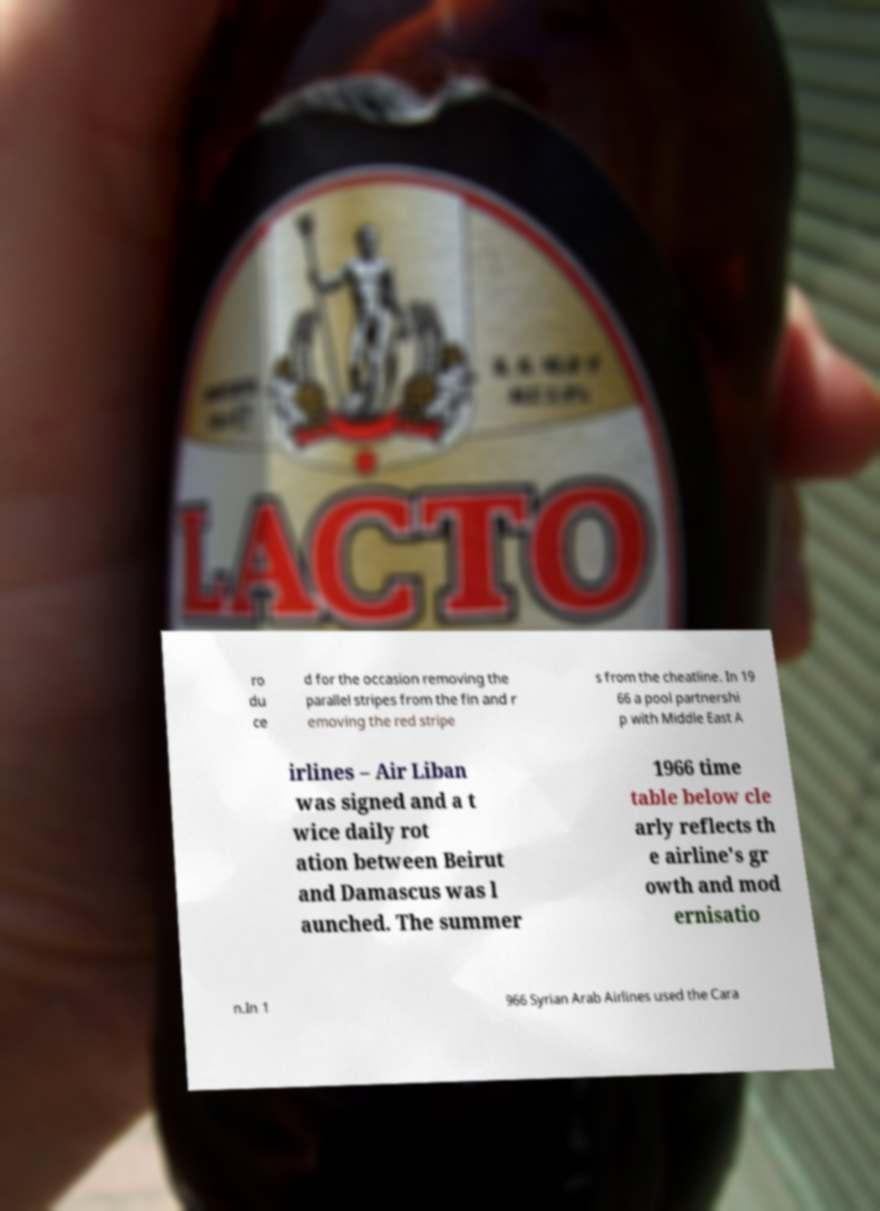For documentation purposes, I need the text within this image transcribed. Could you provide that? ro du ce d for the occasion removing the parallel stripes from the fin and r emoving the red stripe s from the cheatline. In 19 66 a pool partnershi p with Middle East A irlines – Air Liban was signed and a t wice daily rot ation between Beirut and Damascus was l aunched. The summer 1966 time table below cle arly reflects th e airline's gr owth and mod ernisatio n.In 1 966 Syrian Arab Airlines used the Cara 